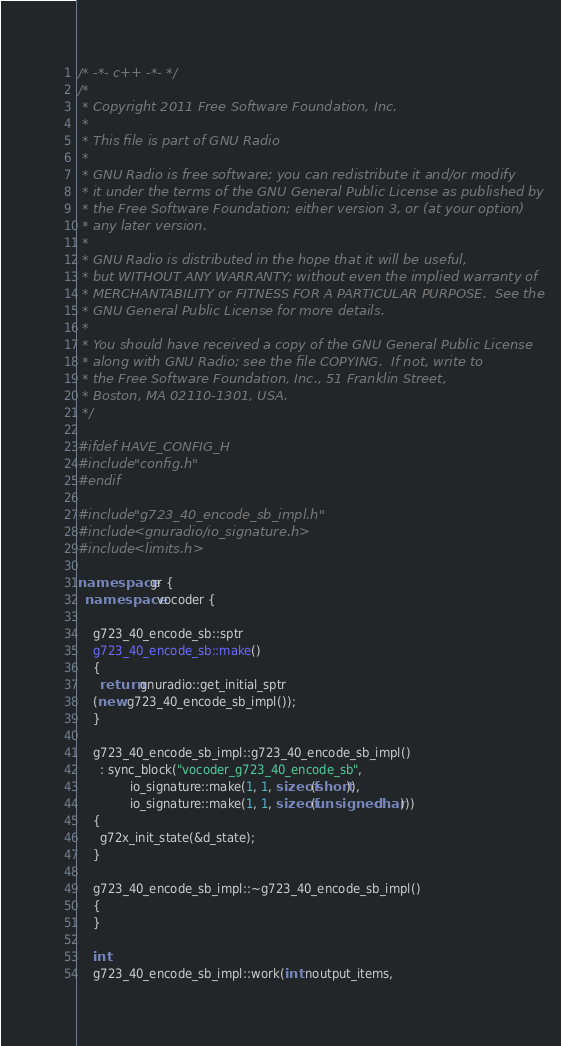<code> <loc_0><loc_0><loc_500><loc_500><_C++_>/* -*- c++ -*- */
/*
 * Copyright 2011 Free Software Foundation, Inc.
 *
 * This file is part of GNU Radio
 *
 * GNU Radio is free software; you can redistribute it and/or modify
 * it under the terms of the GNU General Public License as published by
 * the Free Software Foundation; either version 3, or (at your option)
 * any later version.
 *
 * GNU Radio is distributed in the hope that it will be useful,
 * but WITHOUT ANY WARRANTY; without even the implied warranty of
 * MERCHANTABILITY or FITNESS FOR A PARTICULAR PURPOSE.  See the
 * GNU General Public License for more details.
 *
 * You should have received a copy of the GNU General Public License
 * along with GNU Radio; see the file COPYING.  If not, write to
 * the Free Software Foundation, Inc., 51 Franklin Street,
 * Boston, MA 02110-1301, USA.
 */

#ifdef HAVE_CONFIG_H
#include "config.h"
#endif

#include "g723_40_encode_sb_impl.h"
#include <gnuradio/io_signature.h>
#include <limits.h>

namespace gr {
  namespace vocoder {

    g723_40_encode_sb::sptr
    g723_40_encode_sb::make()
    {
      return gnuradio::get_initial_sptr
	(new g723_40_encode_sb_impl());
    }

    g723_40_encode_sb_impl::g723_40_encode_sb_impl()
      : sync_block("vocoder_g723_40_encode_sb",
		      io_signature::make(1, 1, sizeof(short)),
		      io_signature::make(1, 1, sizeof(unsigned char)))
    {
      g72x_init_state(&d_state);
    }

    g723_40_encode_sb_impl::~g723_40_encode_sb_impl()
    {
    }

    int
    g723_40_encode_sb_impl::work(int noutput_items,</code> 